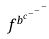Convert formula to latex. <formula><loc_0><loc_0><loc_500><loc_500>f ^ { b ^ { c ^ { - ^ { - ^ { - } } } } }</formula> 